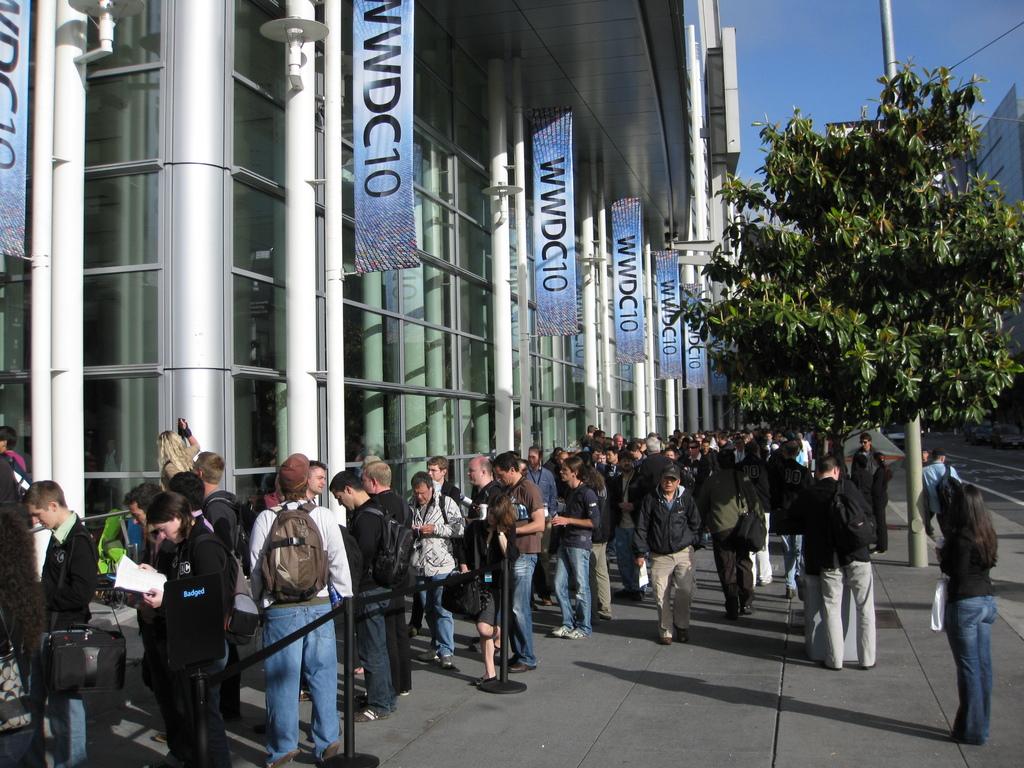What is the name of the building and/or event?
Provide a short and direct response. Wwdc10. 